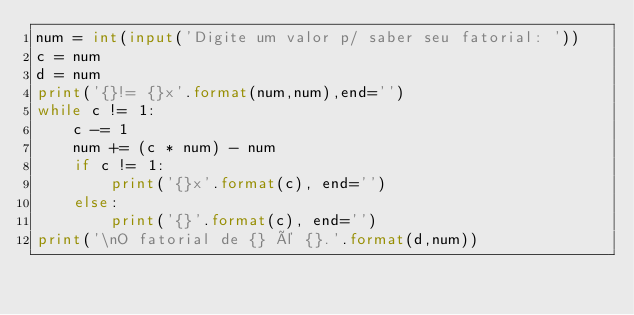Convert code to text. <code><loc_0><loc_0><loc_500><loc_500><_Python_>num = int(input('Digite um valor p/ saber seu fatorial: '))
c = num
d = num
print('{}!= {}x'.format(num,num),end='')
while c != 1:
    c -= 1
    num += (c * num) - num
    if c != 1:
        print('{}x'.format(c), end='')
    else:
        print('{}'.format(c), end='')
print('\nO fatorial de {} é {}.'.format(d,num))
</code> 